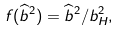<formula> <loc_0><loc_0><loc_500><loc_500>f ( { \widehat { b } } ^ { 2 } ) = { \widehat { b } } ^ { 2 } / b _ { H } ^ { 2 } ,</formula> 